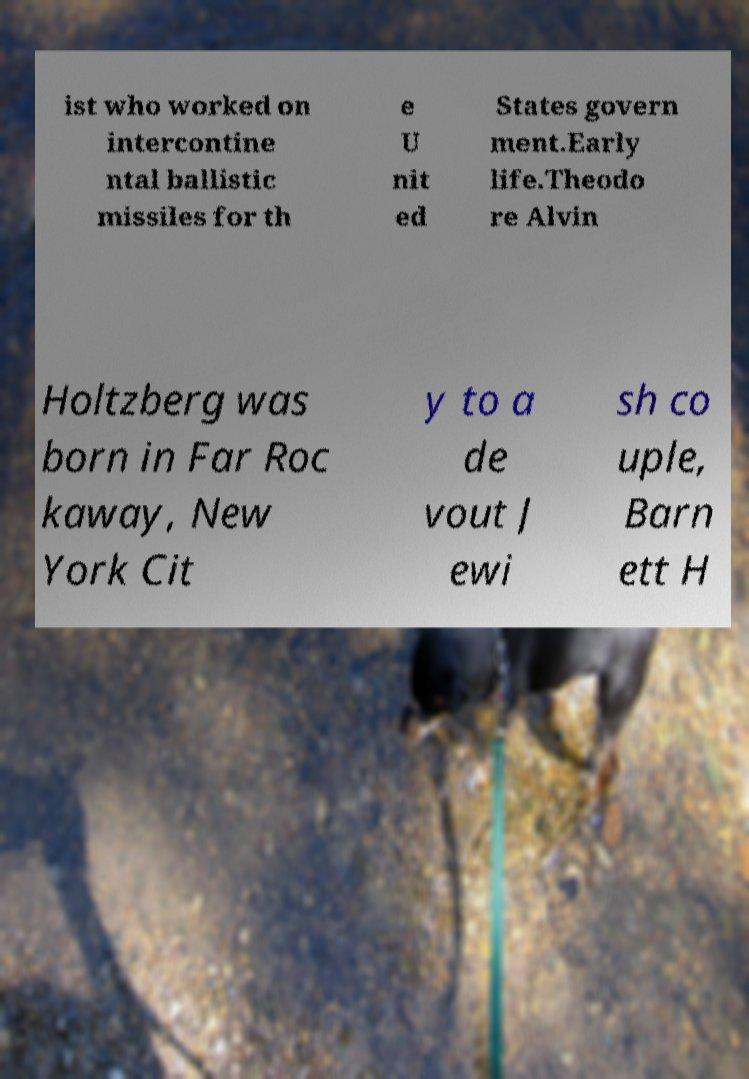Could you assist in decoding the text presented in this image and type it out clearly? ist who worked on intercontine ntal ballistic missiles for th e U nit ed States govern ment.Early life.Theodo re Alvin Holtzberg was born in Far Roc kaway, New York Cit y to a de vout J ewi sh co uple, Barn ett H 